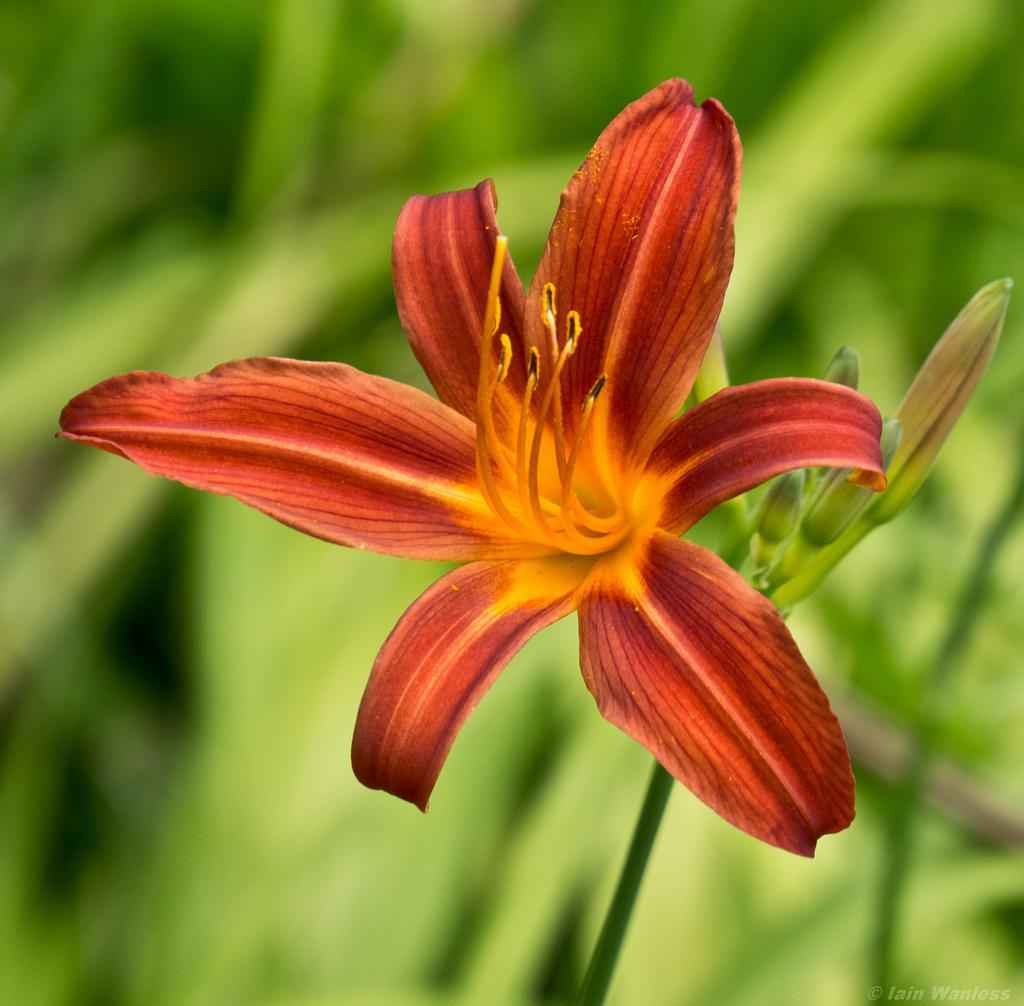Please provide a concise description of this image. In this image at front there is a plant with the red flower on it. 